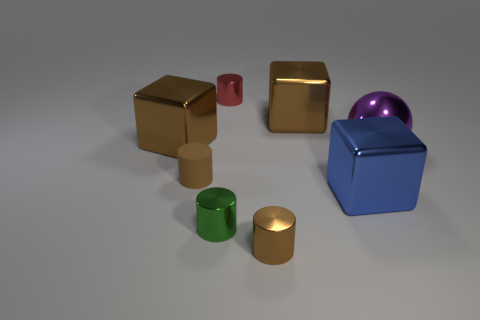What is the red thing made of?
Keep it short and to the point. Metal. There is a large thing in front of the brown matte cylinder; how many cubes are behind it?
Provide a succinct answer. 2. Do the large sphere and the metal cylinder behind the big blue metallic thing have the same color?
Offer a very short reply. No. There is a metallic ball that is the same size as the blue object; what is its color?
Keep it short and to the point. Purple. Is there a tiny cyan matte object that has the same shape as the green metal thing?
Your answer should be compact. No. Is the number of metal cylinders less than the number of green metallic cylinders?
Ensure brevity in your answer.  No. The large cube in front of the rubber object is what color?
Your answer should be very brief. Blue. What is the shape of the tiny metal object behind the object right of the blue thing?
Provide a short and direct response. Cylinder. Are the ball and the tiny brown cylinder in front of the green thing made of the same material?
Your answer should be compact. Yes. What is the shape of the tiny shiny thing that is the same color as the tiny matte cylinder?
Give a very brief answer. Cylinder. 